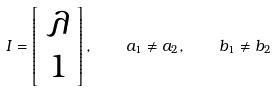<formula> <loc_0><loc_0><loc_500><loc_500>I = \left [ \begin{array} { c } \lambda \\ 1 \end{array} \right ] , \quad a _ { 1 } \neq a _ { 2 } , \quad b _ { 1 } \neq b _ { 2 }</formula> 